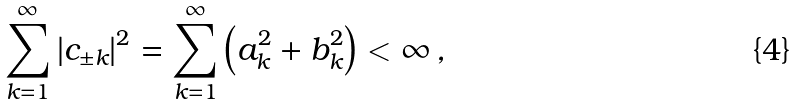Convert formula to latex. <formula><loc_0><loc_0><loc_500><loc_500>\overset { \infty } { \underset { k = 1 } { \sum } } \left | c _ { \pm k } \right | ^ { 2 } = \overset { \infty } { \underset { k = 1 } { \sum } } \left ( a _ { k } ^ { 2 } + b _ { k } ^ { 2 } \right ) < \infty \, ,</formula> 